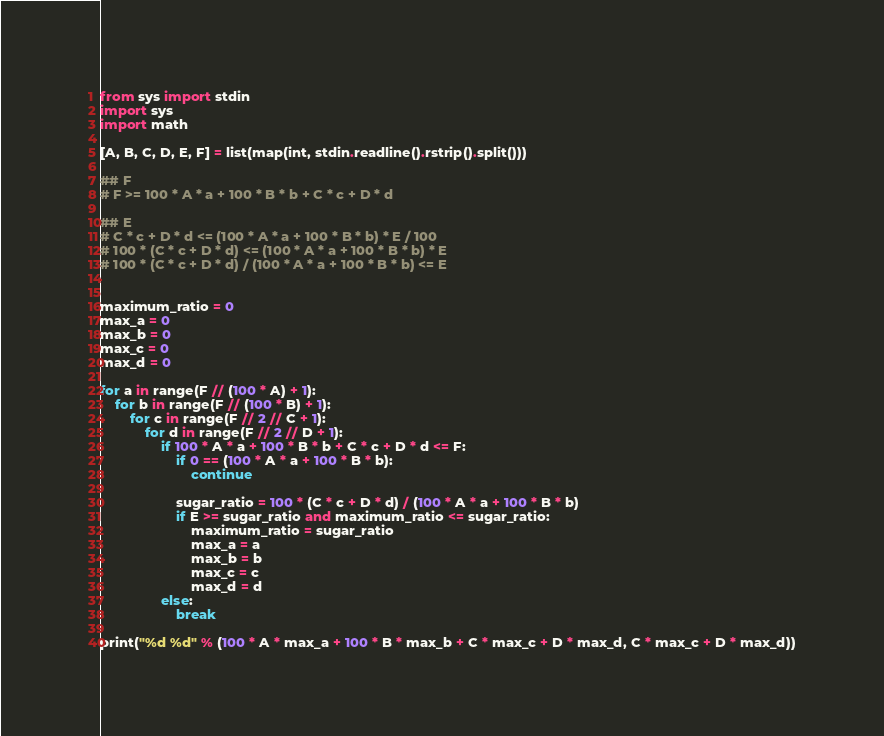Convert code to text. <code><loc_0><loc_0><loc_500><loc_500><_Python_>from sys import stdin
import sys
import math

[A, B, C, D, E, F] = list(map(int, stdin.readline().rstrip().split()))

## F
# F >= 100 * A * a + 100 * B * b + C * c + D * d

## E
# C * c + D * d <= (100 * A * a + 100 * B * b) * E / 100
# 100 * (C * c + D * d) <= (100 * A * a + 100 * B * b) * E
# 100 * (C * c + D * d) / (100 * A * a + 100 * B * b) <= E


maximum_ratio = 0
max_a = 0
max_b = 0
max_c = 0
max_d = 0

for a in range(F // (100 * A) + 1):
    for b in range(F // (100 * B) + 1):
        for c in range(F // 2 // C + 1):
            for d in range(F // 2 // D + 1):
                if 100 * A * a + 100 * B * b + C * c + D * d <= F:
                    if 0 == (100 * A * a + 100 * B * b):
                        continue

                    sugar_ratio = 100 * (C * c + D * d) / (100 * A * a + 100 * B * b)
                    if E >= sugar_ratio and maximum_ratio <= sugar_ratio:
                        maximum_ratio = sugar_ratio
                        max_a = a
                        max_b = b
                        max_c = c
                        max_d = d
                else:
                    break

print("%d %d" % (100 * A * max_a + 100 * B * max_b + C * max_c + D * max_d, C * max_c + D * max_d))
</code> 